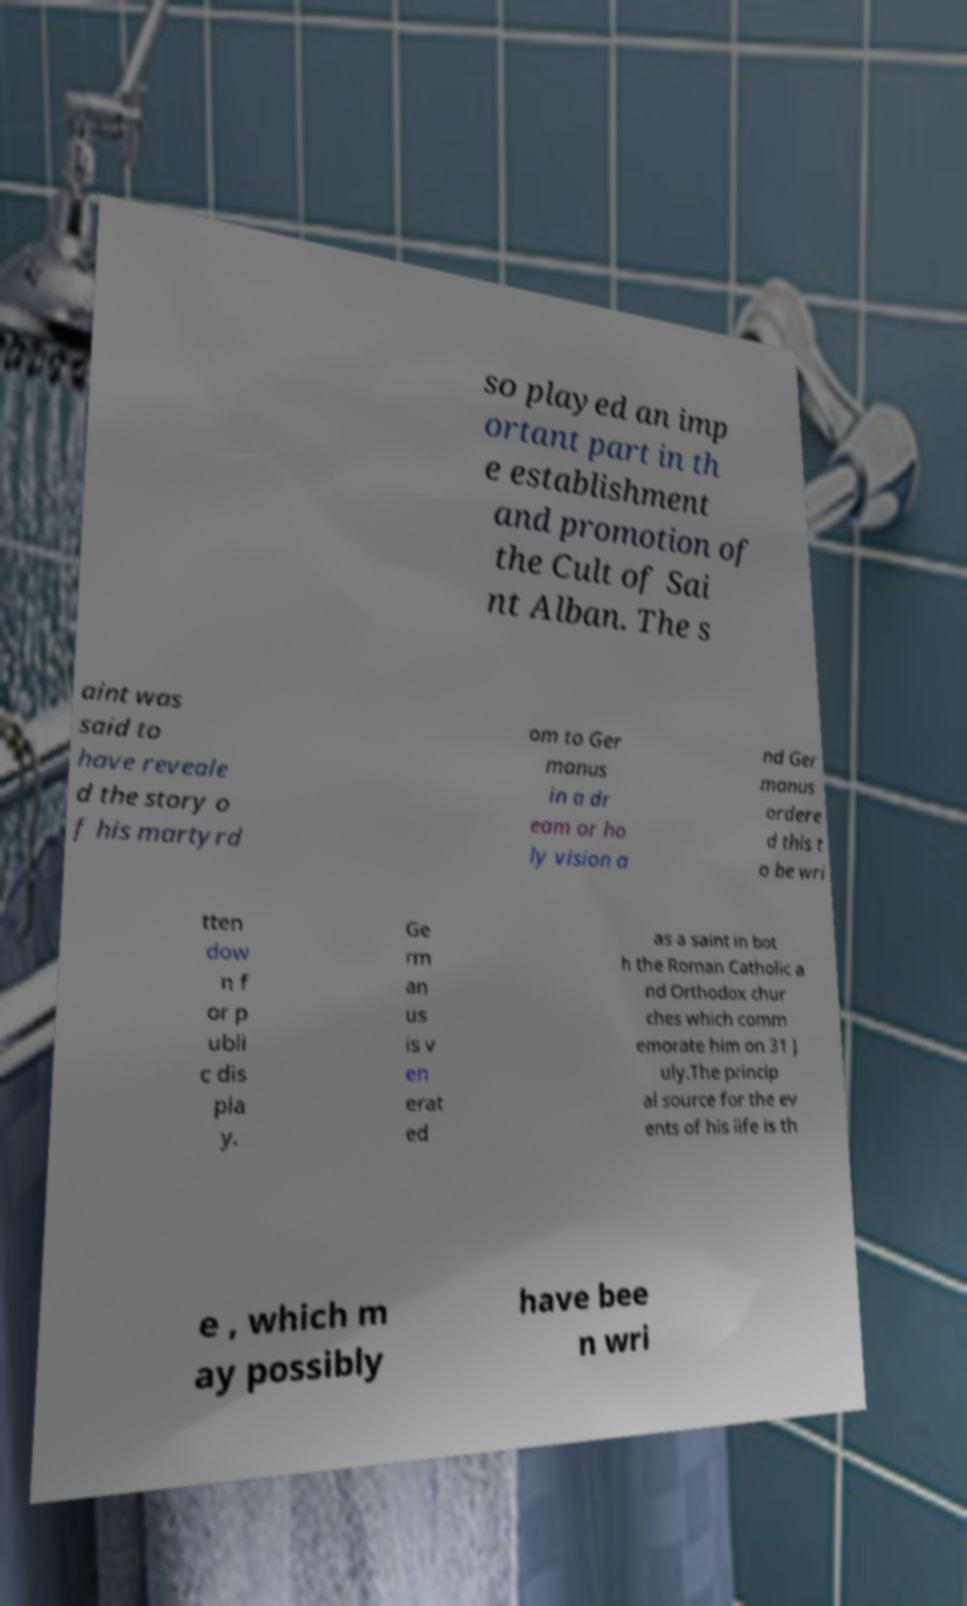Can you accurately transcribe the text from the provided image for me? so played an imp ortant part in th e establishment and promotion of the Cult of Sai nt Alban. The s aint was said to have reveale d the story o f his martyrd om to Ger manus in a dr eam or ho ly vision a nd Ger manus ordere d this t o be wri tten dow n f or p ubli c dis pla y. Ge rm an us is v en erat ed as a saint in bot h the Roman Catholic a nd Orthodox chur ches which comm emorate him on 31 J uly.The princip al source for the ev ents of his life is th e , which m ay possibly have bee n wri 